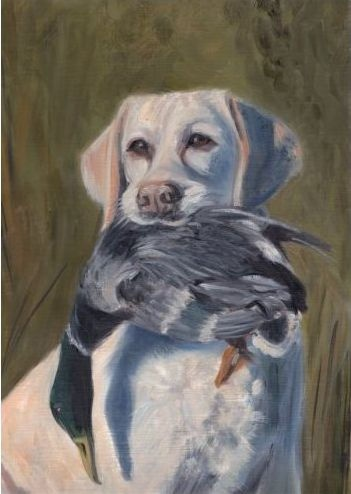Describe the objects in this image and their specific colors. I can see dog in ivory, gray, darkgray, tan, and black tones and bird in ivory, gray, black, and darkgray tones in this image. 